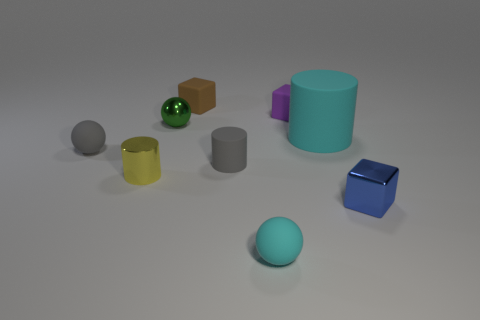Add 1 rubber blocks. How many objects exist? 10 Subtract all tiny cylinders. How many cylinders are left? 1 Subtract all gray blocks. Subtract all brown spheres. How many blocks are left? 3 Subtract all cylinders. How many objects are left? 6 Add 8 small cyan things. How many small cyan things are left? 9 Add 1 large green cylinders. How many large green cylinders exist? 1 Subtract 1 green spheres. How many objects are left? 8 Subtract all yellow cylinders. Subtract all purple matte blocks. How many objects are left? 7 